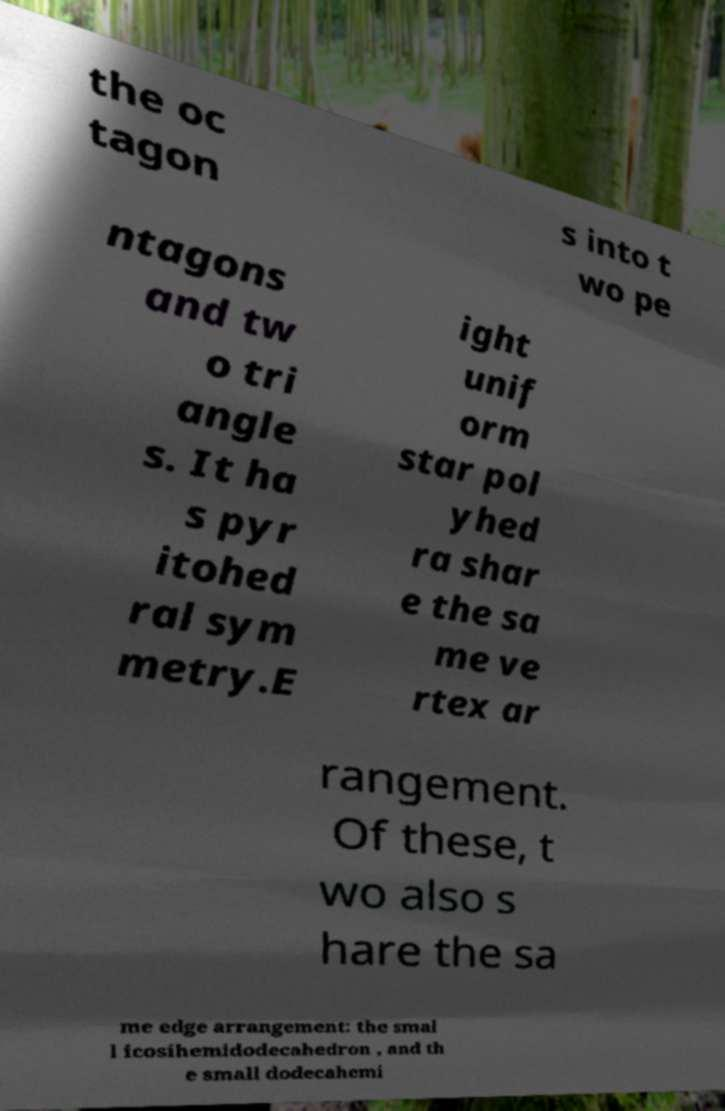What messages or text are displayed in this image? I need them in a readable, typed format. the oc tagon s into t wo pe ntagons and tw o tri angle s. It ha s pyr itohed ral sym metry.E ight unif orm star pol yhed ra shar e the sa me ve rtex ar rangement. Of these, t wo also s hare the sa me edge arrangement: the smal l icosihemidodecahedron , and th e small dodecahemi 